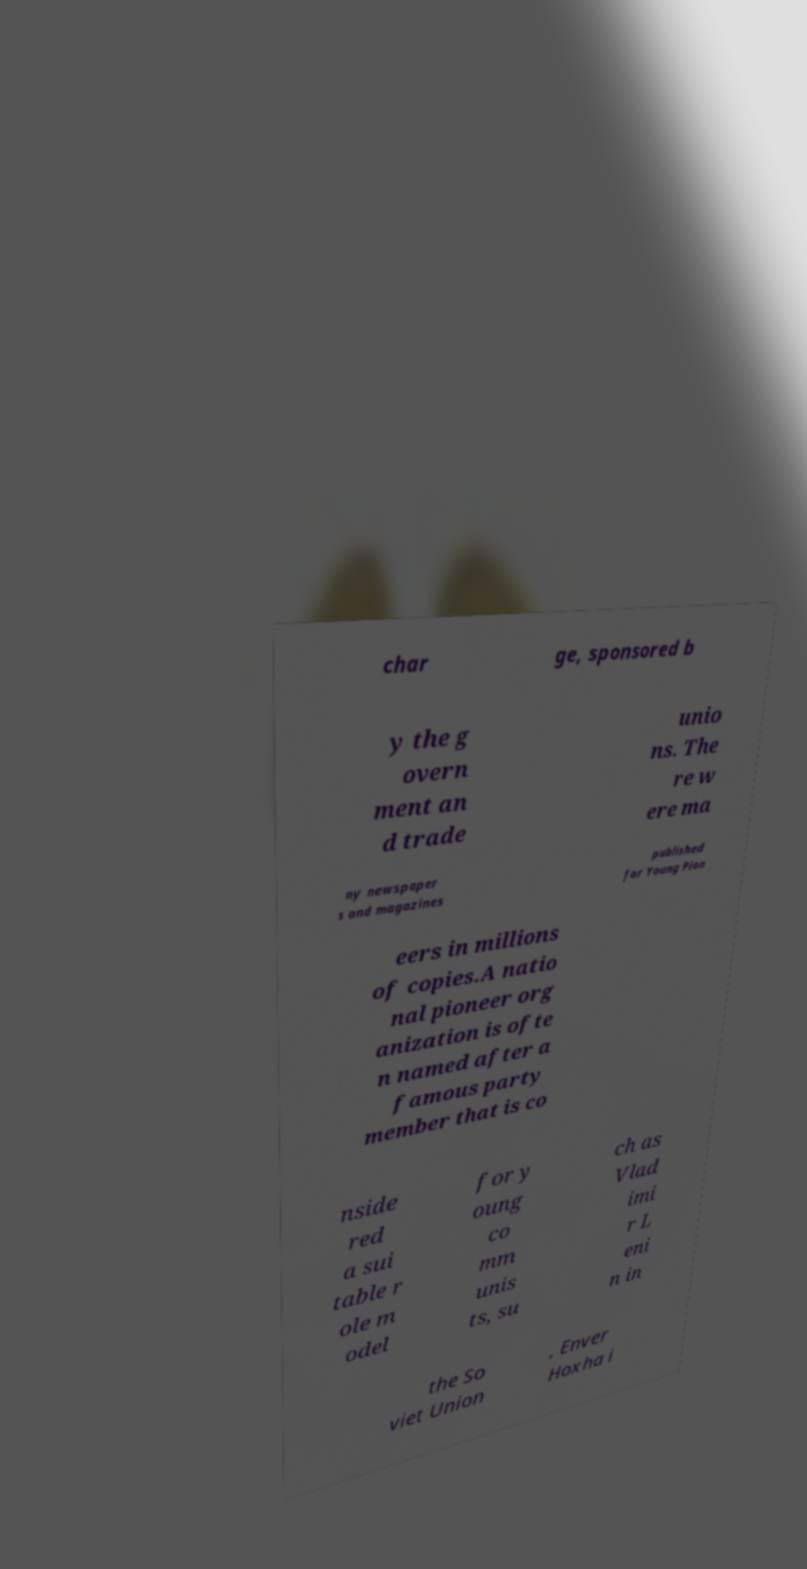Please read and relay the text visible in this image. What does it say? char ge, sponsored b y the g overn ment an d trade unio ns. The re w ere ma ny newspaper s and magazines published for Young Pion eers in millions of copies.A natio nal pioneer org anization is ofte n named after a famous party member that is co nside red a sui table r ole m odel for y oung co mm unis ts, su ch as Vlad imi r L eni n in the So viet Union , Enver Hoxha i 